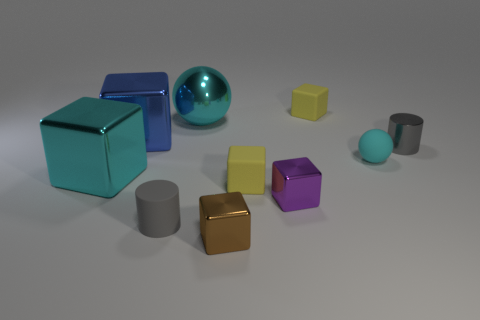How many cyan metallic things are there?
Provide a short and direct response. 2. What number of cyan balls have the same material as the small brown block?
Your answer should be very brief. 1. There is a brown shiny object that is the same shape as the purple metal object; what is its size?
Provide a short and direct response. Small. What is the small cyan sphere made of?
Offer a terse response. Rubber. What material is the big block that is behind the gray cylinder behind the small cylinder that is to the left of the cyan rubber thing made of?
Your response must be concise. Metal. There is another tiny metallic object that is the same shape as the purple object; what is its color?
Provide a short and direct response. Brown. There is a ball in front of the small metal cylinder; does it have the same color as the large object that is in front of the tiny cyan matte sphere?
Keep it short and to the point. Yes. Is the number of blocks left of the tiny brown metal block greater than the number of large yellow metallic cylinders?
Make the answer very short. Yes. How many other objects are there of the same size as the gray rubber thing?
Your answer should be very brief. 6. What number of tiny blocks are in front of the big cyan sphere and behind the big metal ball?
Provide a short and direct response. 0. 